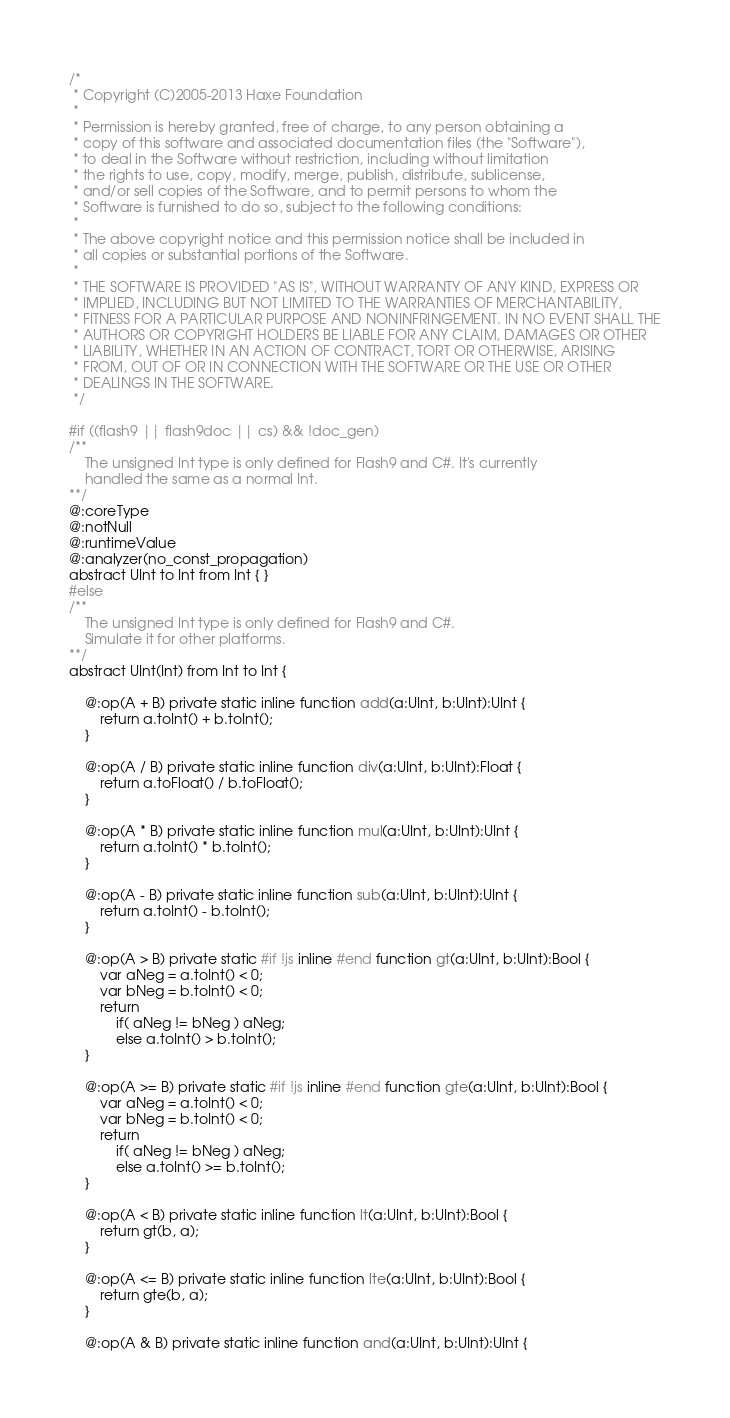<code> <loc_0><loc_0><loc_500><loc_500><_Haxe_>/*
 * Copyright (C)2005-2013 Haxe Foundation
 *
 * Permission is hereby granted, free of charge, to any person obtaining a
 * copy of this software and associated documentation files (the "Software"),
 * to deal in the Software without restriction, including without limitation
 * the rights to use, copy, modify, merge, publish, distribute, sublicense,
 * and/or sell copies of the Software, and to permit persons to whom the
 * Software is furnished to do so, subject to the following conditions:
 *
 * The above copyright notice and this permission notice shall be included in
 * all copies or substantial portions of the Software.
 *
 * THE SOFTWARE IS PROVIDED "AS IS", WITHOUT WARRANTY OF ANY KIND, EXPRESS OR
 * IMPLIED, INCLUDING BUT NOT LIMITED TO THE WARRANTIES OF MERCHANTABILITY,
 * FITNESS FOR A PARTICULAR PURPOSE AND NONINFRINGEMENT. IN NO EVENT SHALL THE
 * AUTHORS OR COPYRIGHT HOLDERS BE LIABLE FOR ANY CLAIM, DAMAGES OR OTHER
 * LIABILITY, WHETHER IN AN ACTION OF CONTRACT, TORT OR OTHERWISE, ARISING
 * FROM, OUT OF OR IN CONNECTION WITH THE SOFTWARE OR THE USE OR OTHER
 * DEALINGS IN THE SOFTWARE.
 */

#if ((flash9 || flash9doc || cs) && !doc_gen)
/**
	The unsigned Int type is only defined for Flash9 and C#. It's currently
	handled the same as a normal Int.
**/
@:coreType
@:notNull
@:runtimeValue
@:analyzer(no_const_propagation)
abstract UInt to Int from Int { }
#else
/**
	The unsigned Int type is only defined for Flash9 and C#.
	Simulate it for other platforms.
**/
abstract UInt(Int) from Int to Int {

	@:op(A + B) private static inline function add(a:UInt, b:UInt):UInt {
		return a.toInt() + b.toInt();
	}

	@:op(A / B) private static inline function div(a:UInt, b:UInt):Float {
		return a.toFloat() / b.toFloat();
	}

	@:op(A * B) private static inline function mul(a:UInt, b:UInt):UInt {
		return a.toInt() * b.toInt();
	}

	@:op(A - B) private static inline function sub(a:UInt, b:UInt):UInt {
		return a.toInt() - b.toInt();
	}

	@:op(A > B) private static #if !js inline #end function gt(a:UInt, b:UInt):Bool {
		var aNeg = a.toInt() < 0;
		var bNeg = b.toInt() < 0;
		return
			if( aNeg != bNeg ) aNeg;
			else a.toInt() > b.toInt();
	}

	@:op(A >= B) private static #if !js inline #end function gte(a:UInt, b:UInt):Bool {
		var aNeg = a.toInt() < 0;
		var bNeg = b.toInt() < 0;
		return
			if( aNeg != bNeg ) aNeg;
			else a.toInt() >= b.toInt();
	}

	@:op(A < B) private static inline function lt(a:UInt, b:UInt):Bool {
		return gt(b, a);
	}

	@:op(A <= B) private static inline function lte(a:UInt, b:UInt):Bool {
		return gte(b, a);
	}

	@:op(A & B) private static inline function and(a:UInt, b:UInt):UInt {</code> 